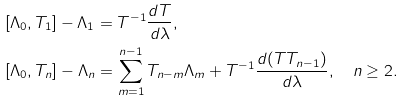<formula> <loc_0><loc_0><loc_500><loc_500>& & & [ \Lambda _ { 0 } , T _ { 1 } ] - \Lambda _ { 1 } = T ^ { - 1 } \frac { d T } { d \lambda } , \\ & & & [ \Lambda _ { 0 } , T _ { n } ] - \Lambda _ { n } = \sum _ { m = 1 } ^ { n - 1 } T _ { n - m } \Lambda _ { m } + T ^ { - 1 } \frac { d ( T T _ { n - 1 } ) } { d \lambda } , \quad n \geq 2 .</formula> 